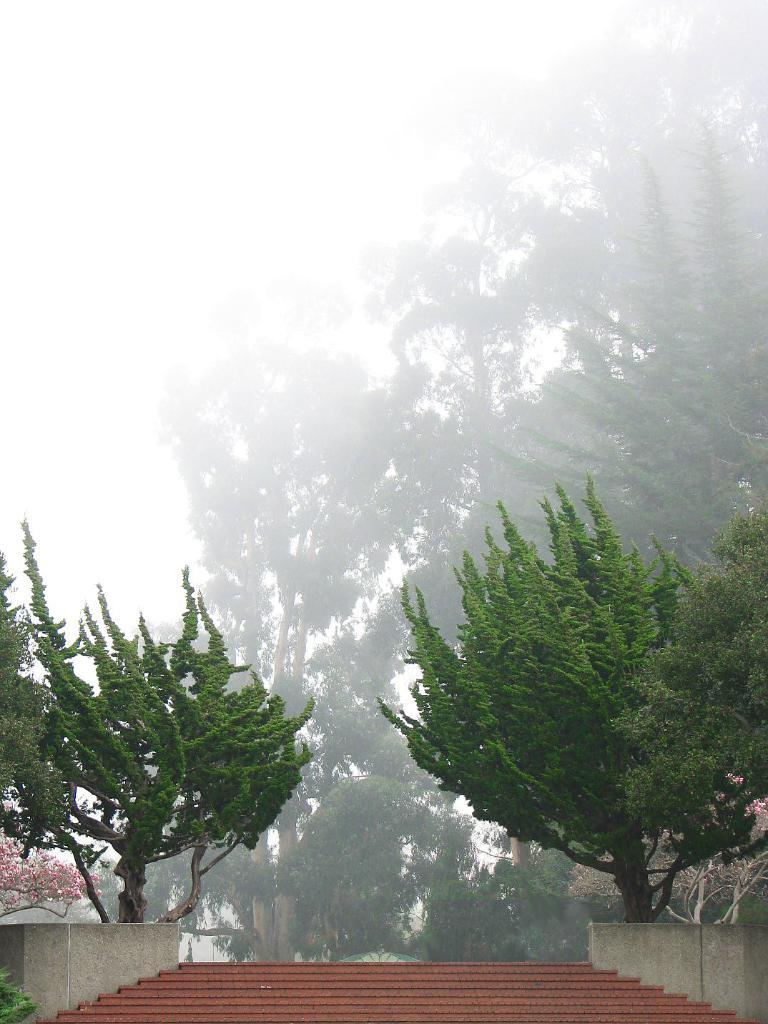What type of vegetation is present in the image? There are many trees in the image. Can you describe any man-made structures in the image? There are brown color stairs in the image. What additional color can be seen on the trees in the image? There are pink color flowers on the trees. What can be seen in the background of the image? The sky is visible in the background of the image. How does the digestion process work for the flowers in the image? The flowers in the image do not have a digestion process, as they are not living organisms. 